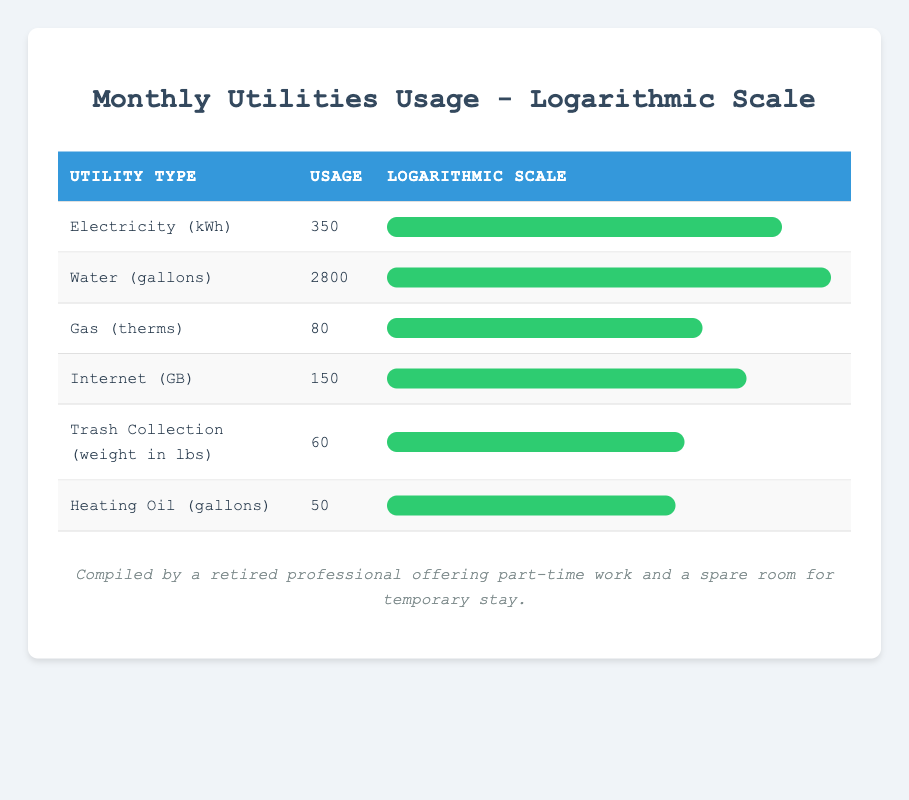What is the usage of Water in gallons? The table lists the usage for Water as 2800 gallons directly in the Usage column for that row.
Answer: 2800 gallons Which utility had the highest usage? By comparing the usage values, Water (2800 gallons) is greater than all other utilities listed, making it the highest.
Answer: Water What is the difference in usage between Gas and Heating Oil? First, the usage for Gas is 80 therms and for Heating Oil is 50 gallons. The difference is calculated as 80 - 50 = 30.
Answer: 30 Is the usage of Electricity higher than that of Trash Collection? The usage for Electricity is 350 kWh and for Trash Collection is 60 lbs. Since 350 is greater than 60, the answer is yes.
Answer: Yes What is the total usage of all utilities combined? The total usage is calculated by summing all the usages: 350 + 2800 + 80 + 150 + 60 + 50 = 3490.
Answer: 3490 What percentage of the total usage does Internet consumption represent? The Internet usage is 150 GB. To find the percentage, calculate (150 / 3490) * 100, which results in approximately 4.29%.
Answer: 4.29% Which utility type has the lowest usage? By reviewing the usage values, Heating Oil (50 gallons) is the lowest compared to the others listed in the table.
Answer: Heating Oil What is the average usage of the utilities listed? To find the average, add all the usages (350 + 2800 + 80 + 150 + 60 + 50) = 3490, then divide by the number of utilities, which is 6. Thus, the average is 3490 / 6 = approximately 581.67.
Answer: 581.67 How much less is the usage of Gas compared to Water? The usage for Gas is 80 therms and for Water is 2800 gallons. The difference is 2800 - 80 = 2720.
Answer: 2720 